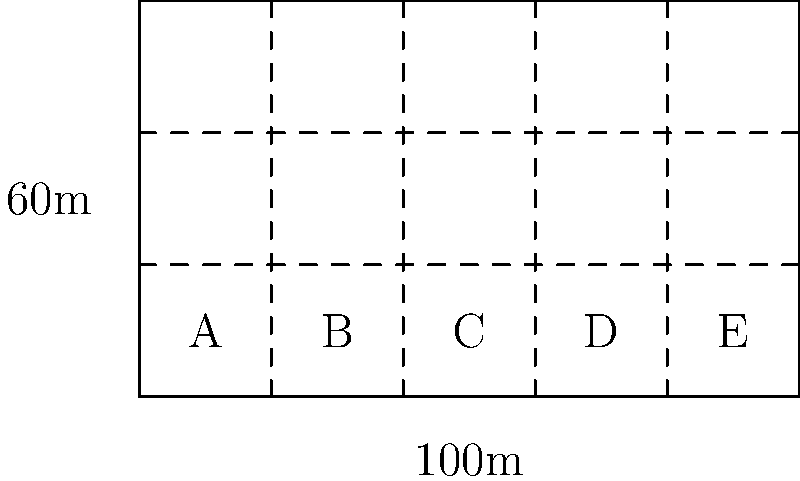You have acquired a rectangular plot of land measuring 100m by 60m. You plan to subdivide it into smaller lots for development. The most efficient layout involves creating 15 equal-sized rectangular lots. If you want to maximize the number of lots with street frontage, how many lots should be placed along the 100m side of the property? Let's approach this step-by-step:

1) We know the total area of the plot: $100m \times 60m = 6000m^2$

2) Since we want 15 equal-sized lots, each lot will have an area of:
   $6000m^2 \div 15 = 400m^2$

3) Let $x$ be the number of lots along the 100m side. Then, $(15 \div x)$ will be the number of lots along the 60m side.

4) The dimensions of each lot will be:
   Width: $100m \div x$
   Length: $60m \div (15 \div x) = 4x$ meters

5) Since each lot has an area of 400m^2, we can set up the equation:
   $(100 \div x) \times 4x = 400$
   $400 = 400$

6) This equation is true for any value of $x$. So, we need to consider our goal of maximizing street frontage.

7) Lots with street frontage will be those along the 100m side. To maximize this, we should choose the largest possible value for $x$ that divides 15 evenly.

8) The factors of 15 are 1, 3, 5, and 15. The largest of these that's less than or equal to 15 is 5.

Therefore, to maximize street frontage, we should place 5 lots along the 100m side.
Answer: 5 lots 